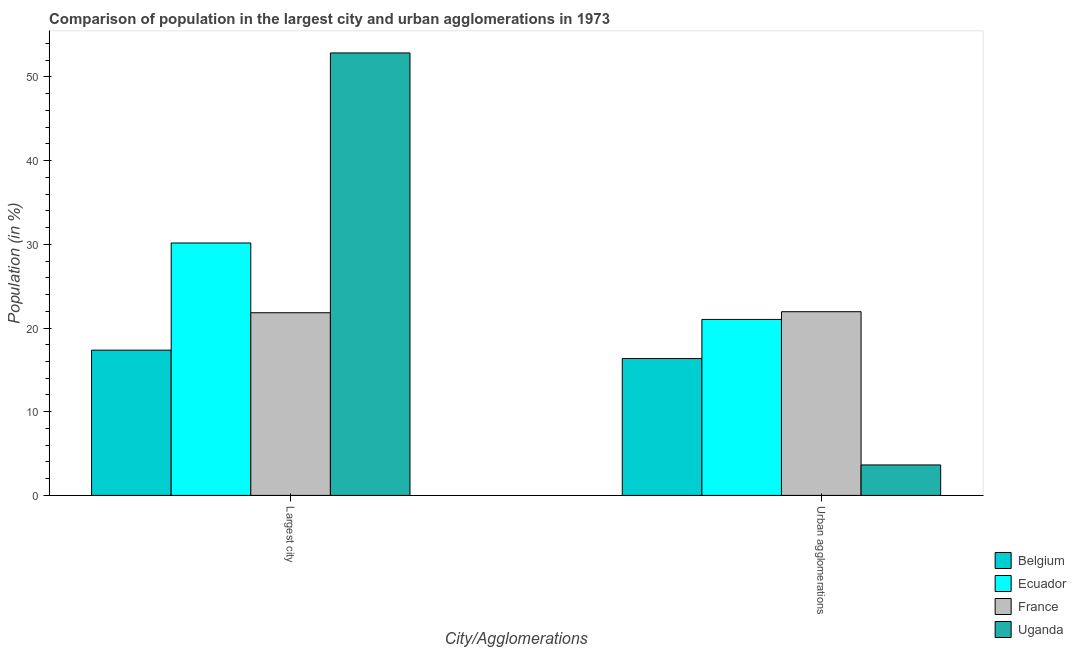How many different coloured bars are there?
Your answer should be very brief. 4. How many groups of bars are there?
Ensure brevity in your answer.  2. How many bars are there on the 2nd tick from the right?
Keep it short and to the point. 4. What is the label of the 1st group of bars from the left?
Keep it short and to the point. Largest city. What is the population in urban agglomerations in Ecuador?
Your response must be concise. 21.02. Across all countries, what is the maximum population in the largest city?
Your answer should be very brief. 52.86. Across all countries, what is the minimum population in the largest city?
Provide a succinct answer. 17.35. In which country was the population in urban agglomerations maximum?
Provide a succinct answer. France. In which country was the population in the largest city minimum?
Offer a terse response. Belgium. What is the total population in urban agglomerations in the graph?
Offer a very short reply. 62.97. What is the difference between the population in the largest city in Ecuador and that in Uganda?
Ensure brevity in your answer.  -22.7. What is the difference between the population in urban agglomerations in Ecuador and the population in the largest city in France?
Offer a terse response. -0.8. What is the average population in the largest city per country?
Offer a terse response. 30.55. What is the difference between the population in urban agglomerations and population in the largest city in Belgium?
Provide a short and direct response. -1. In how many countries, is the population in the largest city greater than 16 %?
Provide a short and direct response. 4. What is the ratio of the population in the largest city in Uganda to that in France?
Provide a succinct answer. 2.42. In how many countries, is the population in the largest city greater than the average population in the largest city taken over all countries?
Keep it short and to the point. 1. What does the 2nd bar from the left in Urban agglomerations represents?
Keep it short and to the point. Ecuador. What does the 3rd bar from the right in Largest city represents?
Offer a terse response. Ecuador. How many bars are there?
Ensure brevity in your answer.  8. Are all the bars in the graph horizontal?
Your answer should be compact. No. Are the values on the major ticks of Y-axis written in scientific E-notation?
Your response must be concise. No. Where does the legend appear in the graph?
Offer a very short reply. Bottom right. How are the legend labels stacked?
Your answer should be compact. Vertical. What is the title of the graph?
Your response must be concise. Comparison of population in the largest city and urban agglomerations in 1973. What is the label or title of the X-axis?
Your answer should be compact. City/Agglomerations. What is the label or title of the Y-axis?
Your answer should be very brief. Population (in %). What is the Population (in %) in Belgium in Largest city?
Your answer should be compact. 17.35. What is the Population (in %) of Ecuador in Largest city?
Keep it short and to the point. 30.16. What is the Population (in %) of France in Largest city?
Give a very brief answer. 21.82. What is the Population (in %) of Uganda in Largest city?
Offer a terse response. 52.86. What is the Population (in %) in Belgium in Urban agglomerations?
Ensure brevity in your answer.  16.35. What is the Population (in %) of Ecuador in Urban agglomerations?
Offer a very short reply. 21.02. What is the Population (in %) in France in Urban agglomerations?
Offer a terse response. 21.95. What is the Population (in %) of Uganda in Urban agglomerations?
Ensure brevity in your answer.  3.64. Across all City/Agglomerations, what is the maximum Population (in %) of Belgium?
Make the answer very short. 17.35. Across all City/Agglomerations, what is the maximum Population (in %) in Ecuador?
Offer a terse response. 30.16. Across all City/Agglomerations, what is the maximum Population (in %) of France?
Your answer should be very brief. 21.95. Across all City/Agglomerations, what is the maximum Population (in %) of Uganda?
Give a very brief answer. 52.86. Across all City/Agglomerations, what is the minimum Population (in %) of Belgium?
Give a very brief answer. 16.35. Across all City/Agglomerations, what is the minimum Population (in %) in Ecuador?
Ensure brevity in your answer.  21.02. Across all City/Agglomerations, what is the minimum Population (in %) in France?
Keep it short and to the point. 21.82. Across all City/Agglomerations, what is the minimum Population (in %) in Uganda?
Provide a short and direct response. 3.64. What is the total Population (in %) in Belgium in the graph?
Give a very brief answer. 33.71. What is the total Population (in %) in Ecuador in the graph?
Your response must be concise. 51.18. What is the total Population (in %) in France in the graph?
Provide a short and direct response. 43.77. What is the total Population (in %) of Uganda in the graph?
Your answer should be very brief. 56.5. What is the difference between the Population (in %) in Belgium in Largest city and that in Urban agglomerations?
Provide a succinct answer. 1. What is the difference between the Population (in %) of Ecuador in Largest city and that in Urban agglomerations?
Make the answer very short. 9.13. What is the difference between the Population (in %) of France in Largest city and that in Urban agglomerations?
Ensure brevity in your answer.  -0.12. What is the difference between the Population (in %) in Uganda in Largest city and that in Urban agglomerations?
Your answer should be very brief. 49.22. What is the difference between the Population (in %) of Belgium in Largest city and the Population (in %) of Ecuador in Urban agglomerations?
Offer a very short reply. -3.67. What is the difference between the Population (in %) in Belgium in Largest city and the Population (in %) in France in Urban agglomerations?
Your response must be concise. -4.59. What is the difference between the Population (in %) of Belgium in Largest city and the Population (in %) of Uganda in Urban agglomerations?
Ensure brevity in your answer.  13.71. What is the difference between the Population (in %) in Ecuador in Largest city and the Population (in %) in France in Urban agglomerations?
Offer a terse response. 8.21. What is the difference between the Population (in %) in Ecuador in Largest city and the Population (in %) in Uganda in Urban agglomerations?
Give a very brief answer. 26.52. What is the difference between the Population (in %) in France in Largest city and the Population (in %) in Uganda in Urban agglomerations?
Give a very brief answer. 18.18. What is the average Population (in %) of Belgium per City/Agglomerations?
Your response must be concise. 16.85. What is the average Population (in %) in Ecuador per City/Agglomerations?
Make the answer very short. 25.59. What is the average Population (in %) of France per City/Agglomerations?
Your response must be concise. 21.89. What is the average Population (in %) in Uganda per City/Agglomerations?
Your answer should be very brief. 28.25. What is the difference between the Population (in %) of Belgium and Population (in %) of Ecuador in Largest city?
Provide a succinct answer. -12.8. What is the difference between the Population (in %) in Belgium and Population (in %) in France in Largest city?
Make the answer very short. -4.47. What is the difference between the Population (in %) in Belgium and Population (in %) in Uganda in Largest city?
Provide a succinct answer. -35.51. What is the difference between the Population (in %) in Ecuador and Population (in %) in France in Largest city?
Offer a very short reply. 8.33. What is the difference between the Population (in %) in Ecuador and Population (in %) in Uganda in Largest city?
Make the answer very short. -22.7. What is the difference between the Population (in %) of France and Population (in %) of Uganda in Largest city?
Your response must be concise. -31.04. What is the difference between the Population (in %) in Belgium and Population (in %) in Ecuador in Urban agglomerations?
Your answer should be compact. -4.67. What is the difference between the Population (in %) in Belgium and Population (in %) in France in Urban agglomerations?
Keep it short and to the point. -5.59. What is the difference between the Population (in %) in Belgium and Population (in %) in Uganda in Urban agglomerations?
Provide a succinct answer. 12.71. What is the difference between the Population (in %) in Ecuador and Population (in %) in France in Urban agglomerations?
Give a very brief answer. -0.92. What is the difference between the Population (in %) in Ecuador and Population (in %) in Uganda in Urban agglomerations?
Offer a very short reply. 17.38. What is the difference between the Population (in %) in France and Population (in %) in Uganda in Urban agglomerations?
Offer a very short reply. 18.31. What is the ratio of the Population (in %) of Belgium in Largest city to that in Urban agglomerations?
Make the answer very short. 1.06. What is the ratio of the Population (in %) of Ecuador in Largest city to that in Urban agglomerations?
Your answer should be very brief. 1.43. What is the ratio of the Population (in %) in Uganda in Largest city to that in Urban agglomerations?
Keep it short and to the point. 14.52. What is the difference between the highest and the second highest Population (in %) in Belgium?
Keep it short and to the point. 1. What is the difference between the highest and the second highest Population (in %) of Ecuador?
Your answer should be compact. 9.13. What is the difference between the highest and the second highest Population (in %) in France?
Offer a very short reply. 0.12. What is the difference between the highest and the second highest Population (in %) in Uganda?
Your response must be concise. 49.22. What is the difference between the highest and the lowest Population (in %) in Belgium?
Your answer should be compact. 1. What is the difference between the highest and the lowest Population (in %) in Ecuador?
Offer a terse response. 9.13. What is the difference between the highest and the lowest Population (in %) in France?
Ensure brevity in your answer.  0.12. What is the difference between the highest and the lowest Population (in %) of Uganda?
Provide a short and direct response. 49.22. 